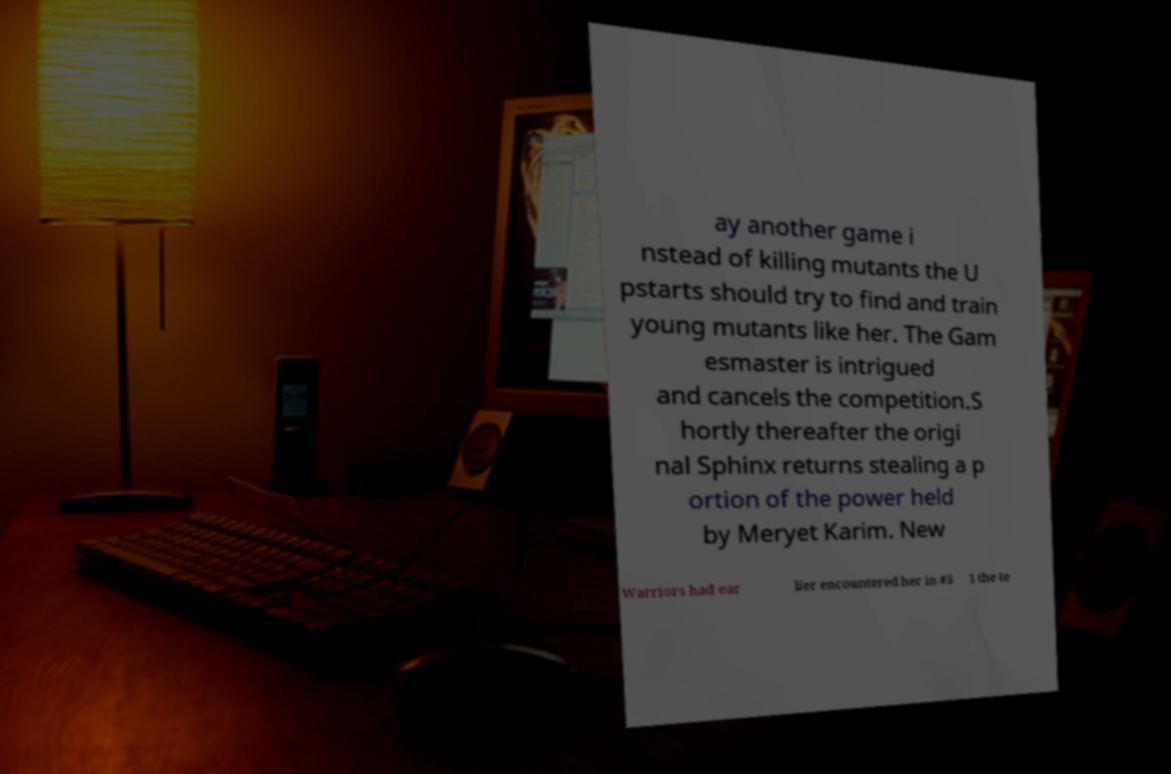What messages or text are displayed in this image? I need them in a readable, typed format. ay another game i nstead of killing mutants the U pstarts should try to find and train young mutants like her. The Gam esmaster is intrigued and cancels the competition.S hortly thereafter the origi nal Sphinx returns stealing a p ortion of the power held by Meryet Karim. New Warriors had ear lier encountered her in #5 1 the te 